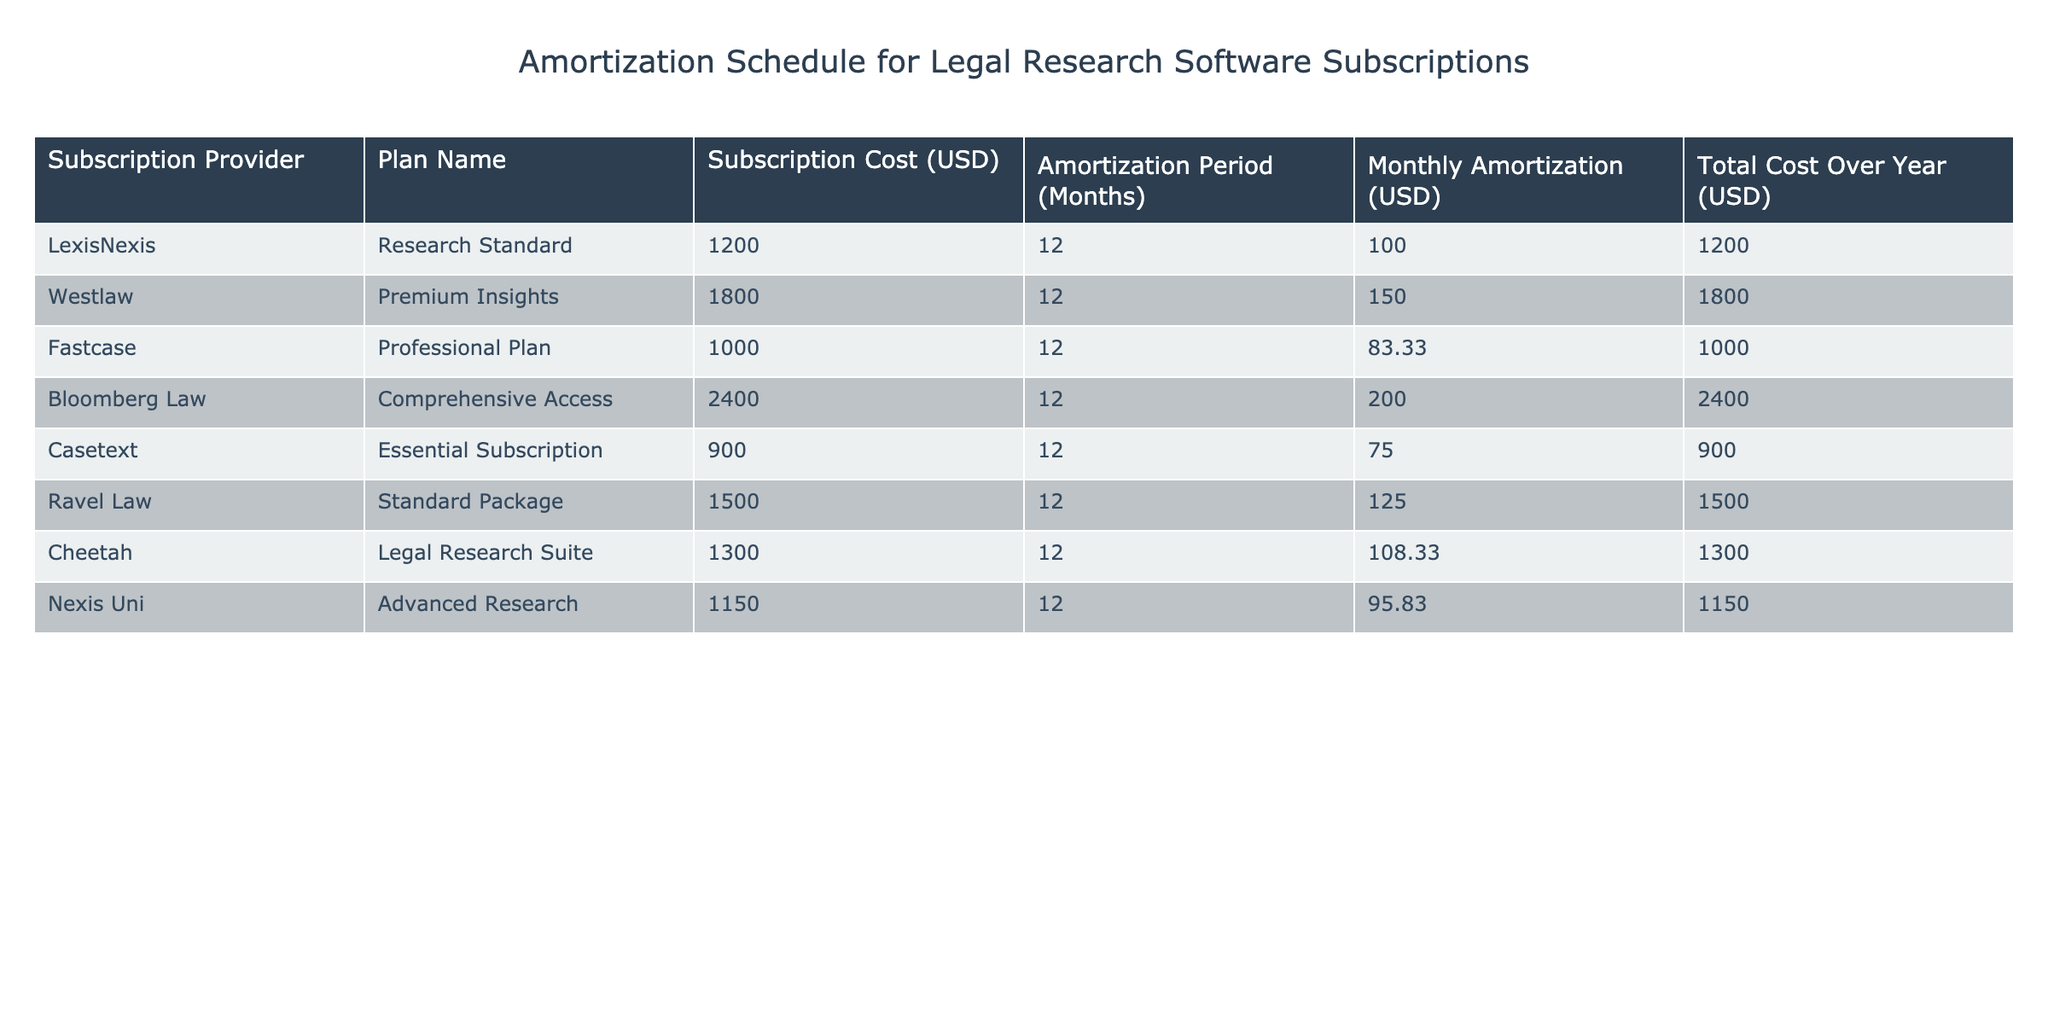What is the monthly amortization cost for the LexisNexis Research Standard plan? The table lists the monthly amortization cost for different plans. For LexisNexis, the corresponding value in the 'Monthly Amortization (USD)' column is 100.
Answer: 100 Which subscription provider has the highest total cost over the year? To find the highest total cost over the year, we examine the 'Total Cost Over Year (USD)' column. Bloomberg Law has the highest value of 2400.
Answer: Bloomberg Law What is the average monthly amortization cost across all providers? To find the average, sum the monthly amortization costs (100 + 150 + 83.33 + 200 + 75 + 125 + 108.33 + 95.83 = 933.49) and divide by the number of providers (8). This gives us an average of 116.68625, rounded to 116.69.
Answer: 116.69 Is the monthly amortization for the Fastcase Professional Plan lower than the LexisNexis Research Standard plan? The monthly amortization for Fastcase is 83.33 and for LexisNexis, it is 100. Since 83.33 is less than 100, the statement is true.
Answer: Yes What is the difference between the total costs of the highest and lowest subscription providers? The highest total cost is given by Bloomberg Law at 2400, and the lowest is Casetext at 900. The difference is calculated as 2400 - 900 = 1500.
Answer: 1500 Which subscription plan has a monthly amortization cost closest to 125? Looking through the 'Monthly Amortization (USD)' column, the Ravel Law Standard Package has a value of 125 exactly. This is the only plan that matches this monthly payment.
Answer: Ravel Law Does Nexis Uni have a higher subscription cost than Casetext? According to the table, Nexis Uni's subscription cost is 1150 and Casetext's is 900. Since 1150 is greater than 900, the answer is yes.
Answer: Yes What is the total subscription cost of all software providers combined? We sum the values in the 'Subscription Cost (USD)' column: 1200 + 1800 + 1000 + 2400 + 900 + 1500 + 1300 + 1150 = 10950.
Answer: 10950 